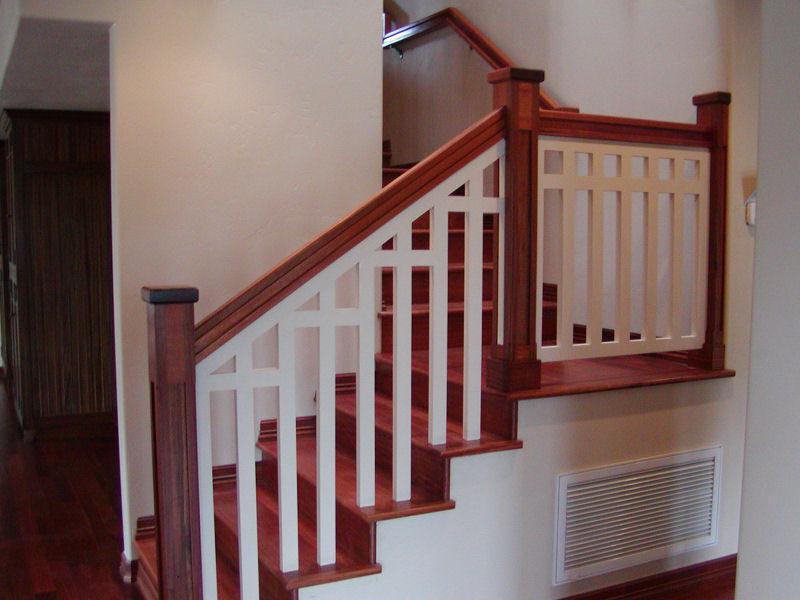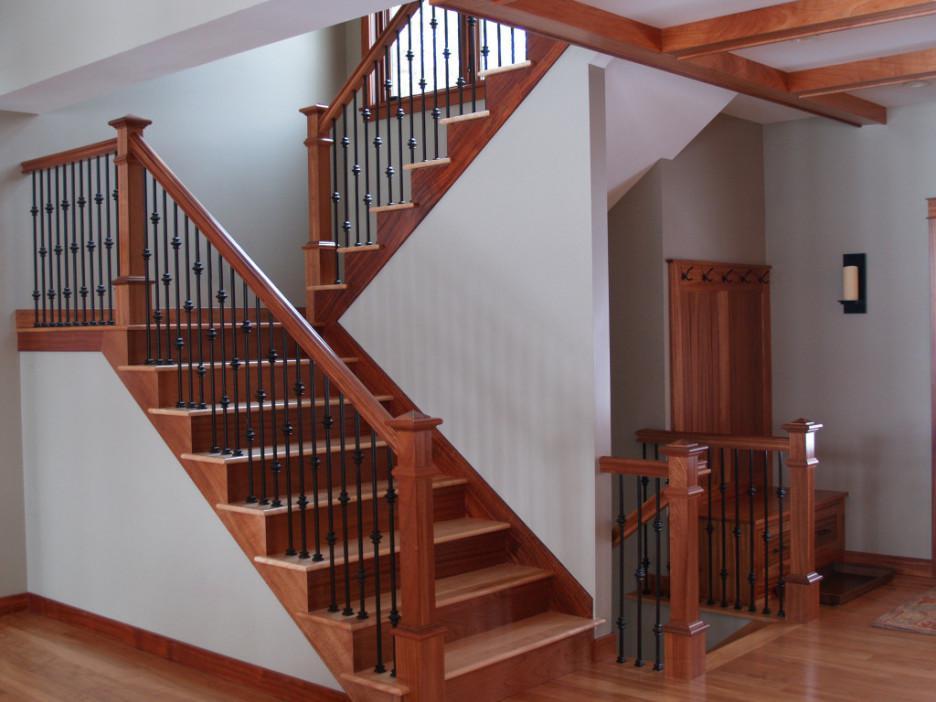The first image is the image on the left, the second image is the image on the right. Analyze the images presented: Is the assertion "The left image shows a staircase with a closed-in bottom and the edges of the stairs visible from the side, and the staircase ascends to the right, then turns leftward." valid? Answer yes or no. Yes. 